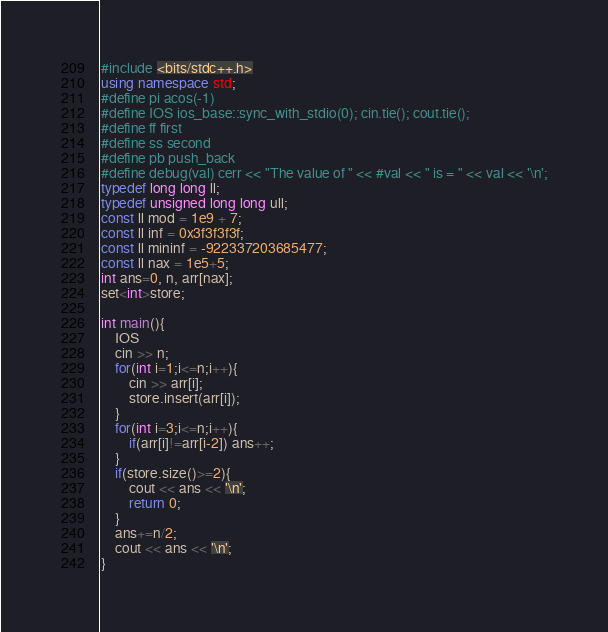<code> <loc_0><loc_0><loc_500><loc_500><_C++_>#include <bits/stdc++.h>
using namespace std;
#define pi acos(-1)
#define IOS ios_base::sync_with_stdio(0); cin.tie(); cout.tie();
#define ff first
#define ss second
#define pb push_back
#define debug(val) cerr << "The value of " << #val << " is = " << val << '\n';
typedef long long ll;
typedef unsigned long long ull;
const ll mod = 1e9 + 7;
const ll inf = 0x3f3f3f3f;
const ll mininf = -922337203685477;
const ll nax = 1e5+5;
int ans=0, n, arr[nax];
set<int>store;

int main(){
	IOS
	cin >> n;
	for(int i=1;i<=n;i++){
		cin >> arr[i];
		store.insert(arr[i]);			
	}
	for(int i=3;i<=n;i++){
		if(arr[i]!=arr[i-2]) ans++;
	}
	if(store.size()>=2){
		cout << ans << '\n';
		return 0;
	}
	ans+=n/2;
	cout << ans << '\n';
}
</code> 